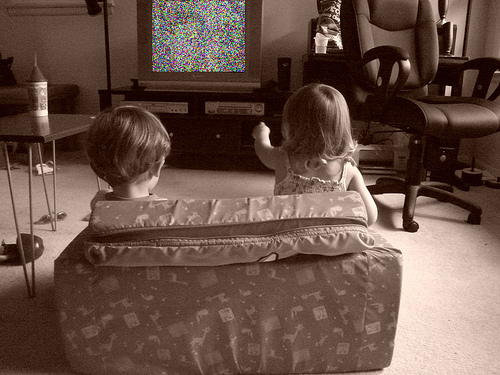What might the children feel while watching a static screen? The children might feel a blend of disappointment and confusion seeing the static screen instead of their expected programming. Such a situation could lead to them feeling unsure about what has happened and possibly prompt them to ask an adult for help or resolve the issue themselves. 